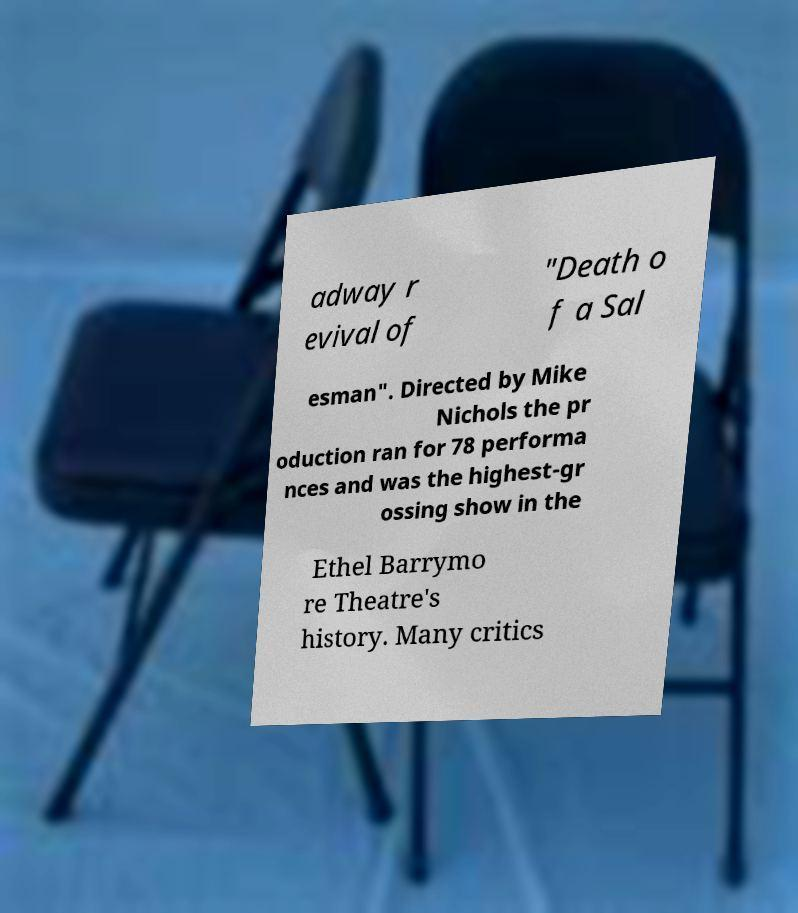Could you extract and type out the text from this image? adway r evival of "Death o f a Sal esman". Directed by Mike Nichols the pr oduction ran for 78 performa nces and was the highest-gr ossing show in the Ethel Barrymo re Theatre's history. Many critics 